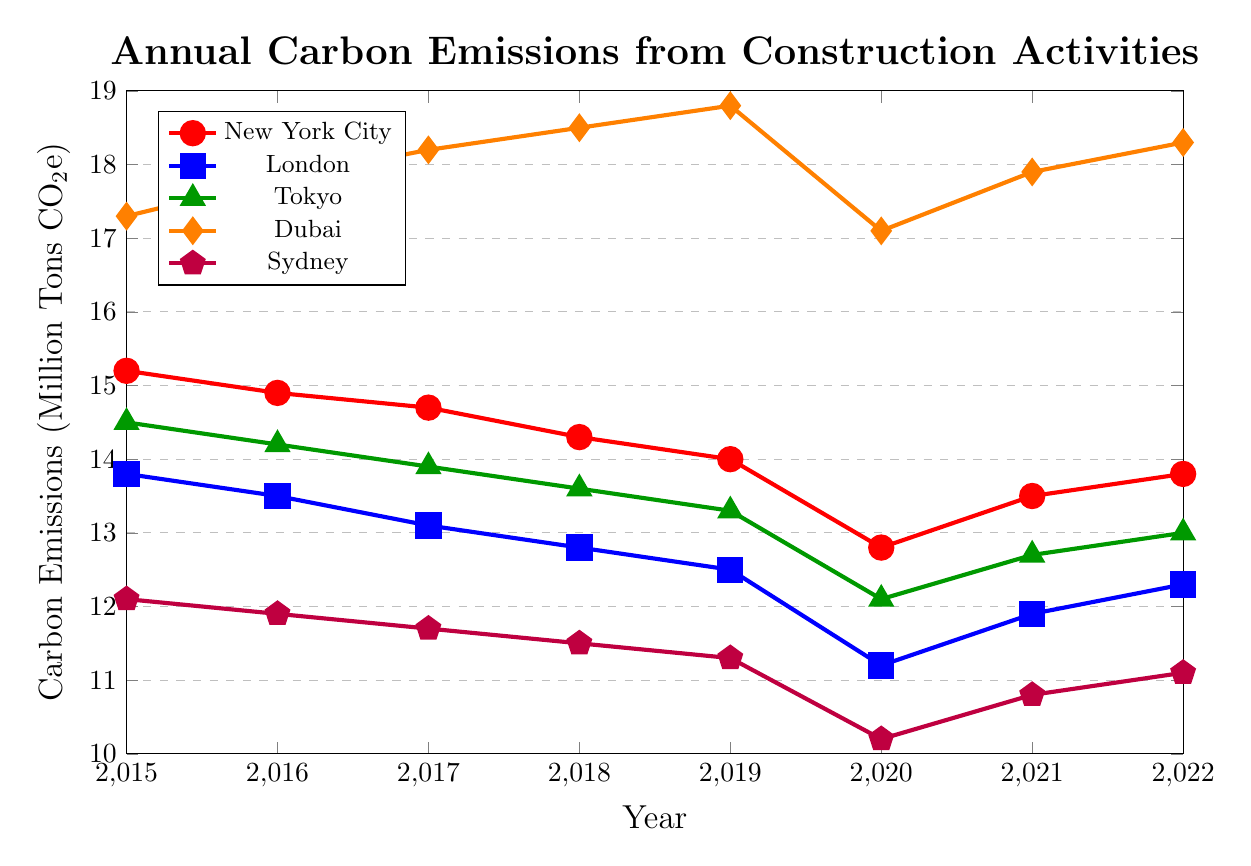Which city had the highest carbon emissions in 2022? The legend shows that Dubai had the highest carbon emissions in 2022. This is indicated by the orange line, which is higher than the others in 2022.
Answer: Dubai What is the trend in carbon emissions for New York City from 2015 to 2022? By following the red line, you can see it generally decreases from 15.2 million tons in 2015 to 12.8 million tons in 2020 before increasing again to 13.8 million tons in 2022.
Answer: Decreasing then increasing At which year did Tokyo have the lowest carbon emissions? The green line shows Tokyo's carbon emissions; the lowest point on this line is in 2020 at 12.1 million tons.
Answer: 2020 How did the carbon emissions of Sydney change from 2019 to 2020? The purple line shows Sydney’s carbon emissions; from 2019 to 2020, the emissions decreased from 11.3 million tons to 10.2 million tons.
Answer: Decreased Which city saw the most significant reduction in carbon emissions from 2015 to 2020? Compare the start and end points on the plot for each city from 2015 to 2020. New York City’s emissions dropped from 15.2 to 12.8 million tons, which is the largest drop of 2.4 million tons.
Answer: New York City Was there any year when London’s carbon emissions increased compared to the previous year? By following the blue line, London’s emissions increased from 11.2 in 2020 to 11.9 million tons in 2021.
Answer: Yes In 2017, which city had the second highest carbon emissions, and what was the value? The orange, red, blue, green, and purple lines from highest to lowest in 2017 show Dubai had the highest, followed by New York City with 14.7 million tons.
Answer: New York City, 14.7 million tons What is the average annual carbon emissions of Tokyo from 2015 to 2022? Sum Tokyo’s values (14.5 + 14.2 + 13.9 + 13.6 + 13.3 + 12.1 + 12.7 + 13.0) = 107.3 million tons, then divide by 8 years = 107.3/8 = approximately 13.4 million tons.
Answer: 13.4 million tons Compare the carbon emissions of New York City and Dubai in 2020, and find the difference. In 2020, New York City had 12.8 million tons and Dubai had 17.1 million tons. The difference is 17.1 - 12.8 = 4.3 million tons.
Answer: 4.3 million tons From 2015 to 2022, in which years did Sydney have carbon emissions less than 11 million tons? The purple line shows Sydney’s emissions below 11 in 2020 (10.2), 2021 (10.8), and 2022 (11.1 is not less than 11).
Answer: 2020, 2021 